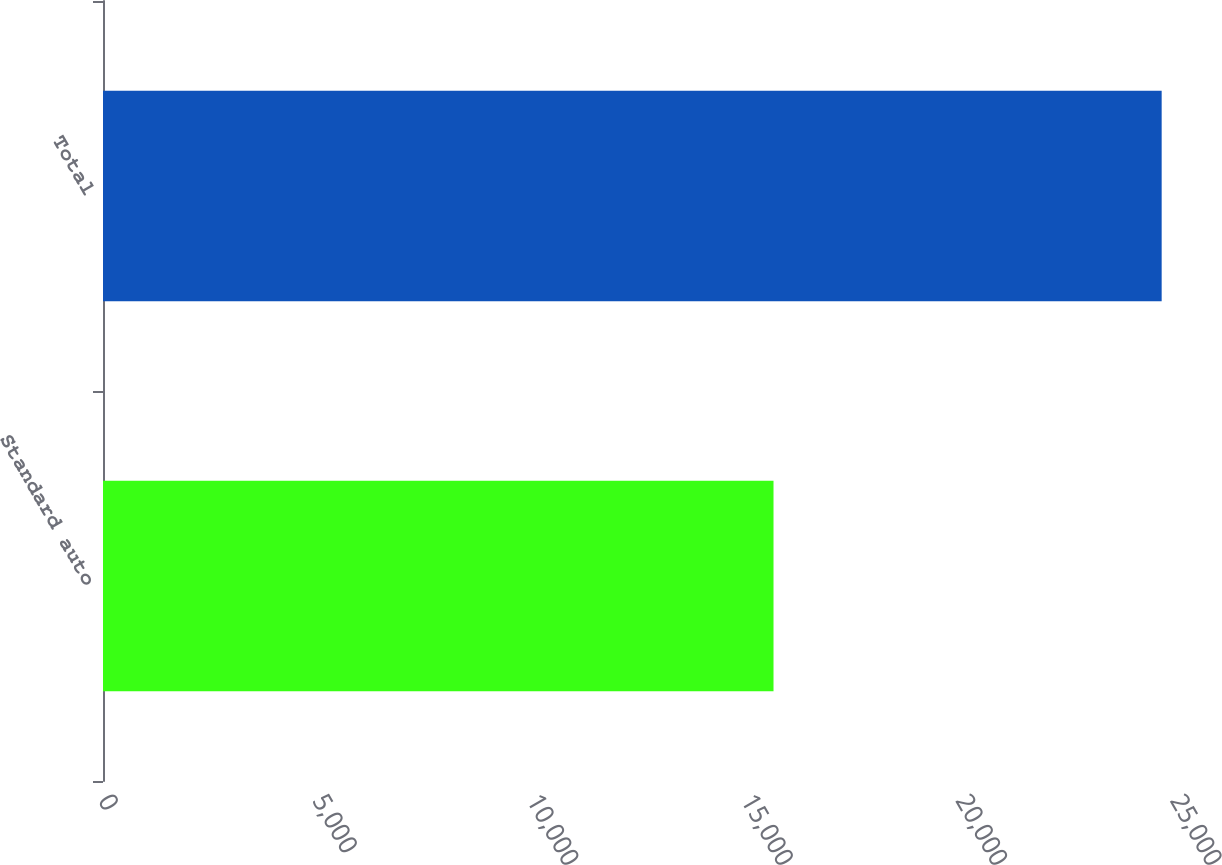Convert chart to OTSL. <chart><loc_0><loc_0><loc_500><loc_500><bar_chart><fcel>Standard auto<fcel>Total<nl><fcel>15637<fcel>24689<nl></chart> 